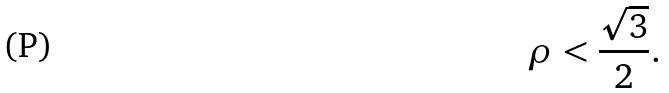Convert formula to latex. <formula><loc_0><loc_0><loc_500><loc_500>\rho < \frac { \sqrt { 3 } } { 2 } .</formula> 